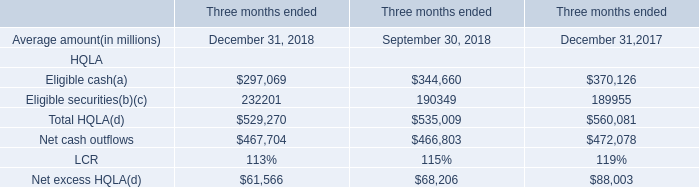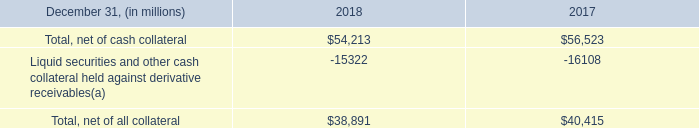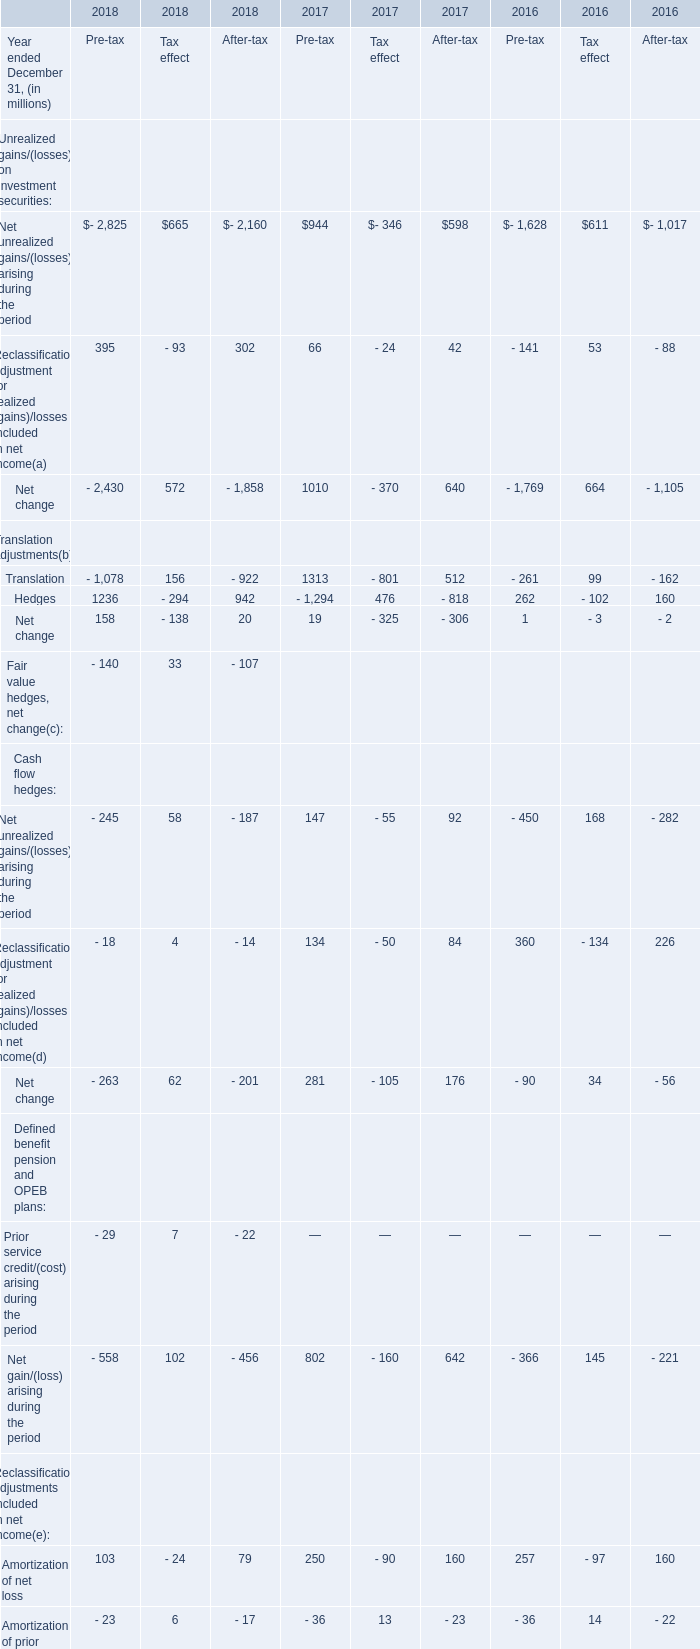In the year with lowest amount of Net unrealized gains/(losses) arising during the periodthe, what's the increasing rate of Reclassification adjustment for realized (gains)/losses included in net income? 
Computations: ((((395 - 93) + 302) - ((66 - 24) + 42)) / ((66 - 24) + 42))
Answer: 6.19048. 